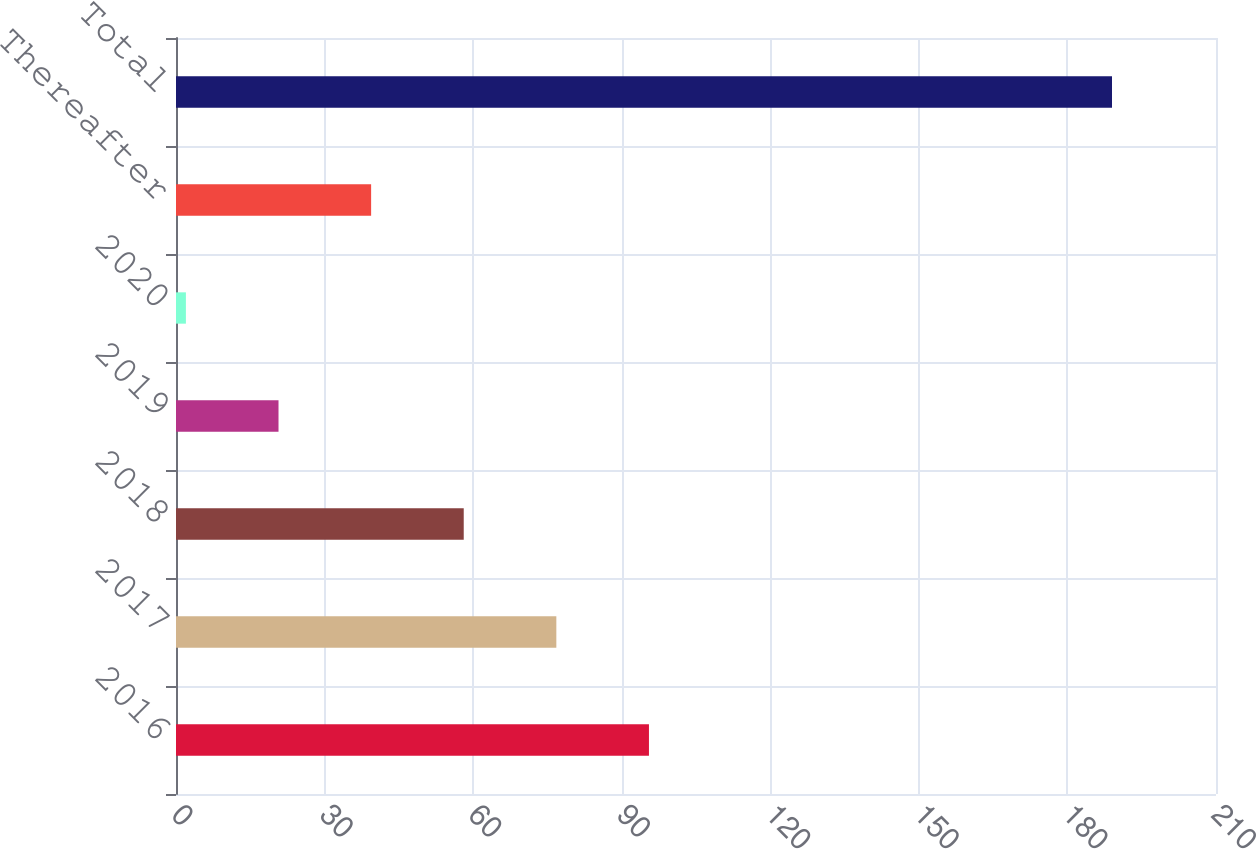<chart> <loc_0><loc_0><loc_500><loc_500><bar_chart><fcel>2016<fcel>2017<fcel>2018<fcel>2019<fcel>2020<fcel>Thereafter<fcel>Total<nl><fcel>95.5<fcel>76.8<fcel>58.1<fcel>20.7<fcel>2<fcel>39.4<fcel>189<nl></chart> 